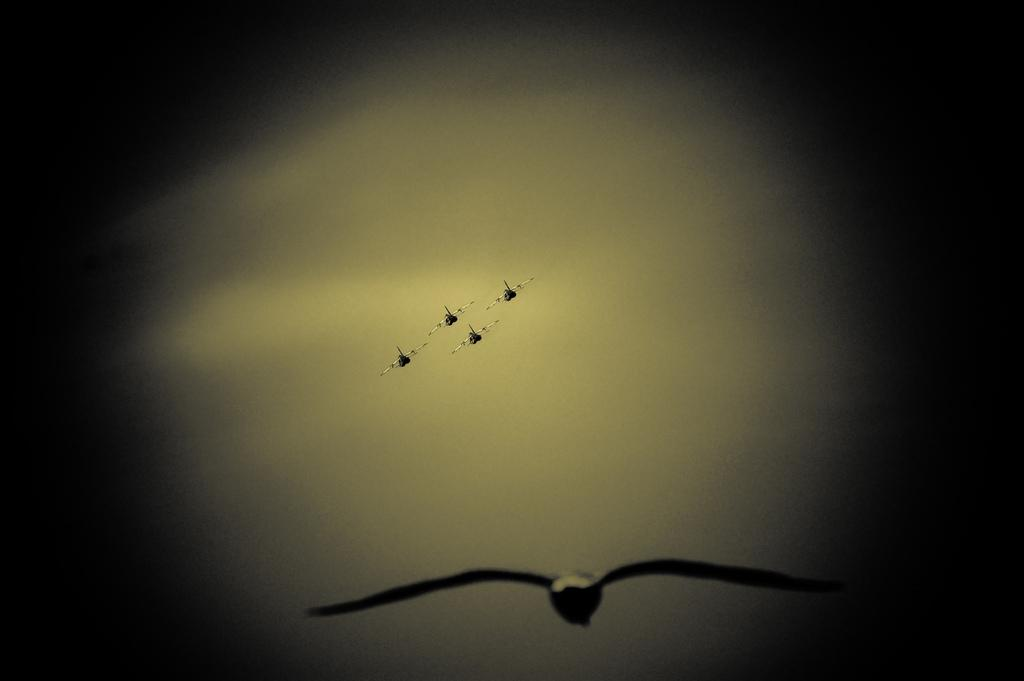How many airplanes are present in the image? There are four airplanes in the image. What is visible in the background of the image? There is a sky visible in the background of the image. What can be seen in the sky? There are clouds in the sky. What type of hose is being used to connect the airplanes in the image? There is no hose present in the image; the airplanes are not connected. 